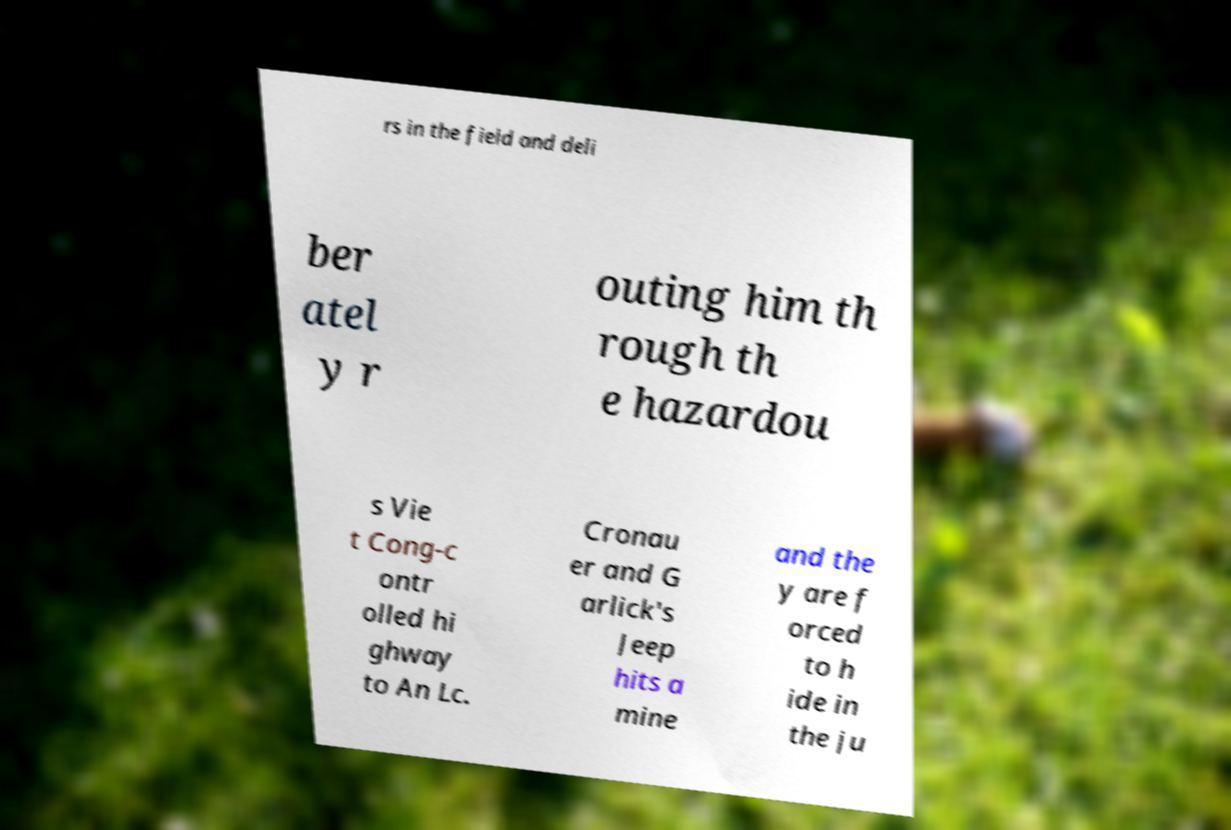Please identify and transcribe the text found in this image. rs in the field and deli ber atel y r outing him th rough th e hazardou s Vie t Cong-c ontr olled hi ghway to An Lc. Cronau er and G arlick's Jeep hits a mine and the y are f orced to h ide in the ju 